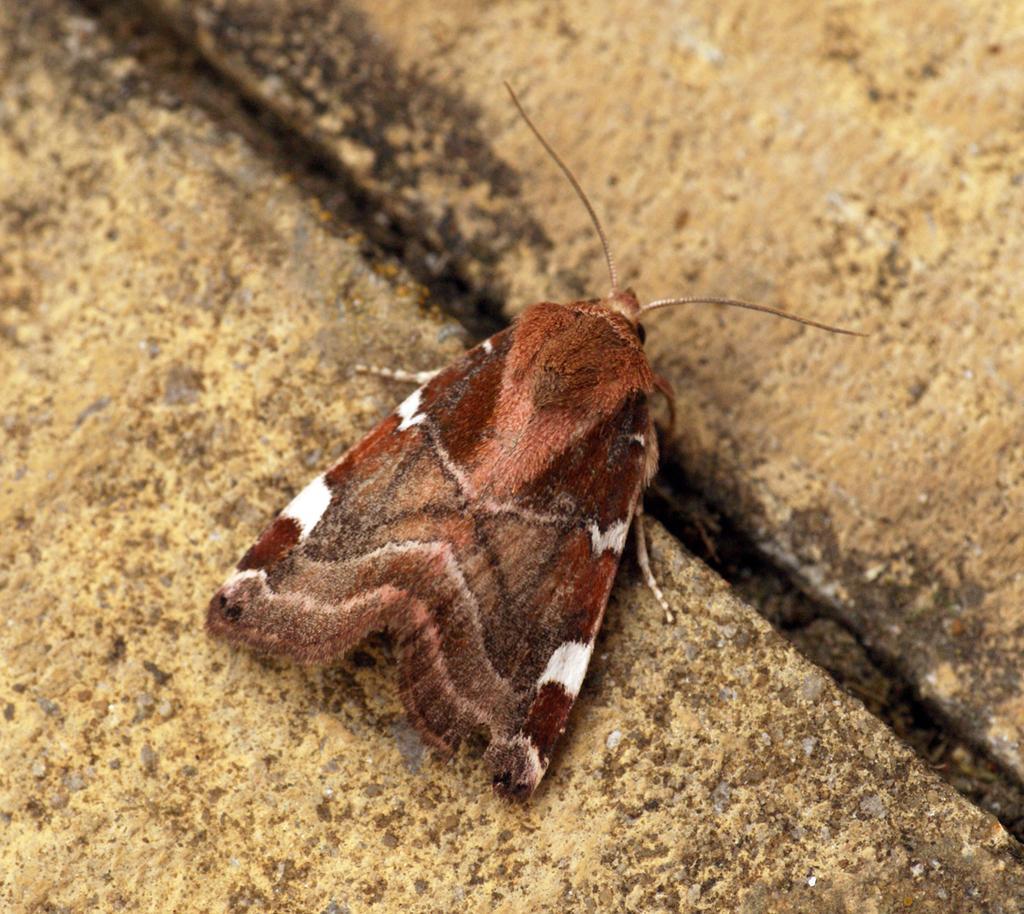Could you give a brief overview of what you see in this image? In this picture there is a butterfly who is standing on the floor. 